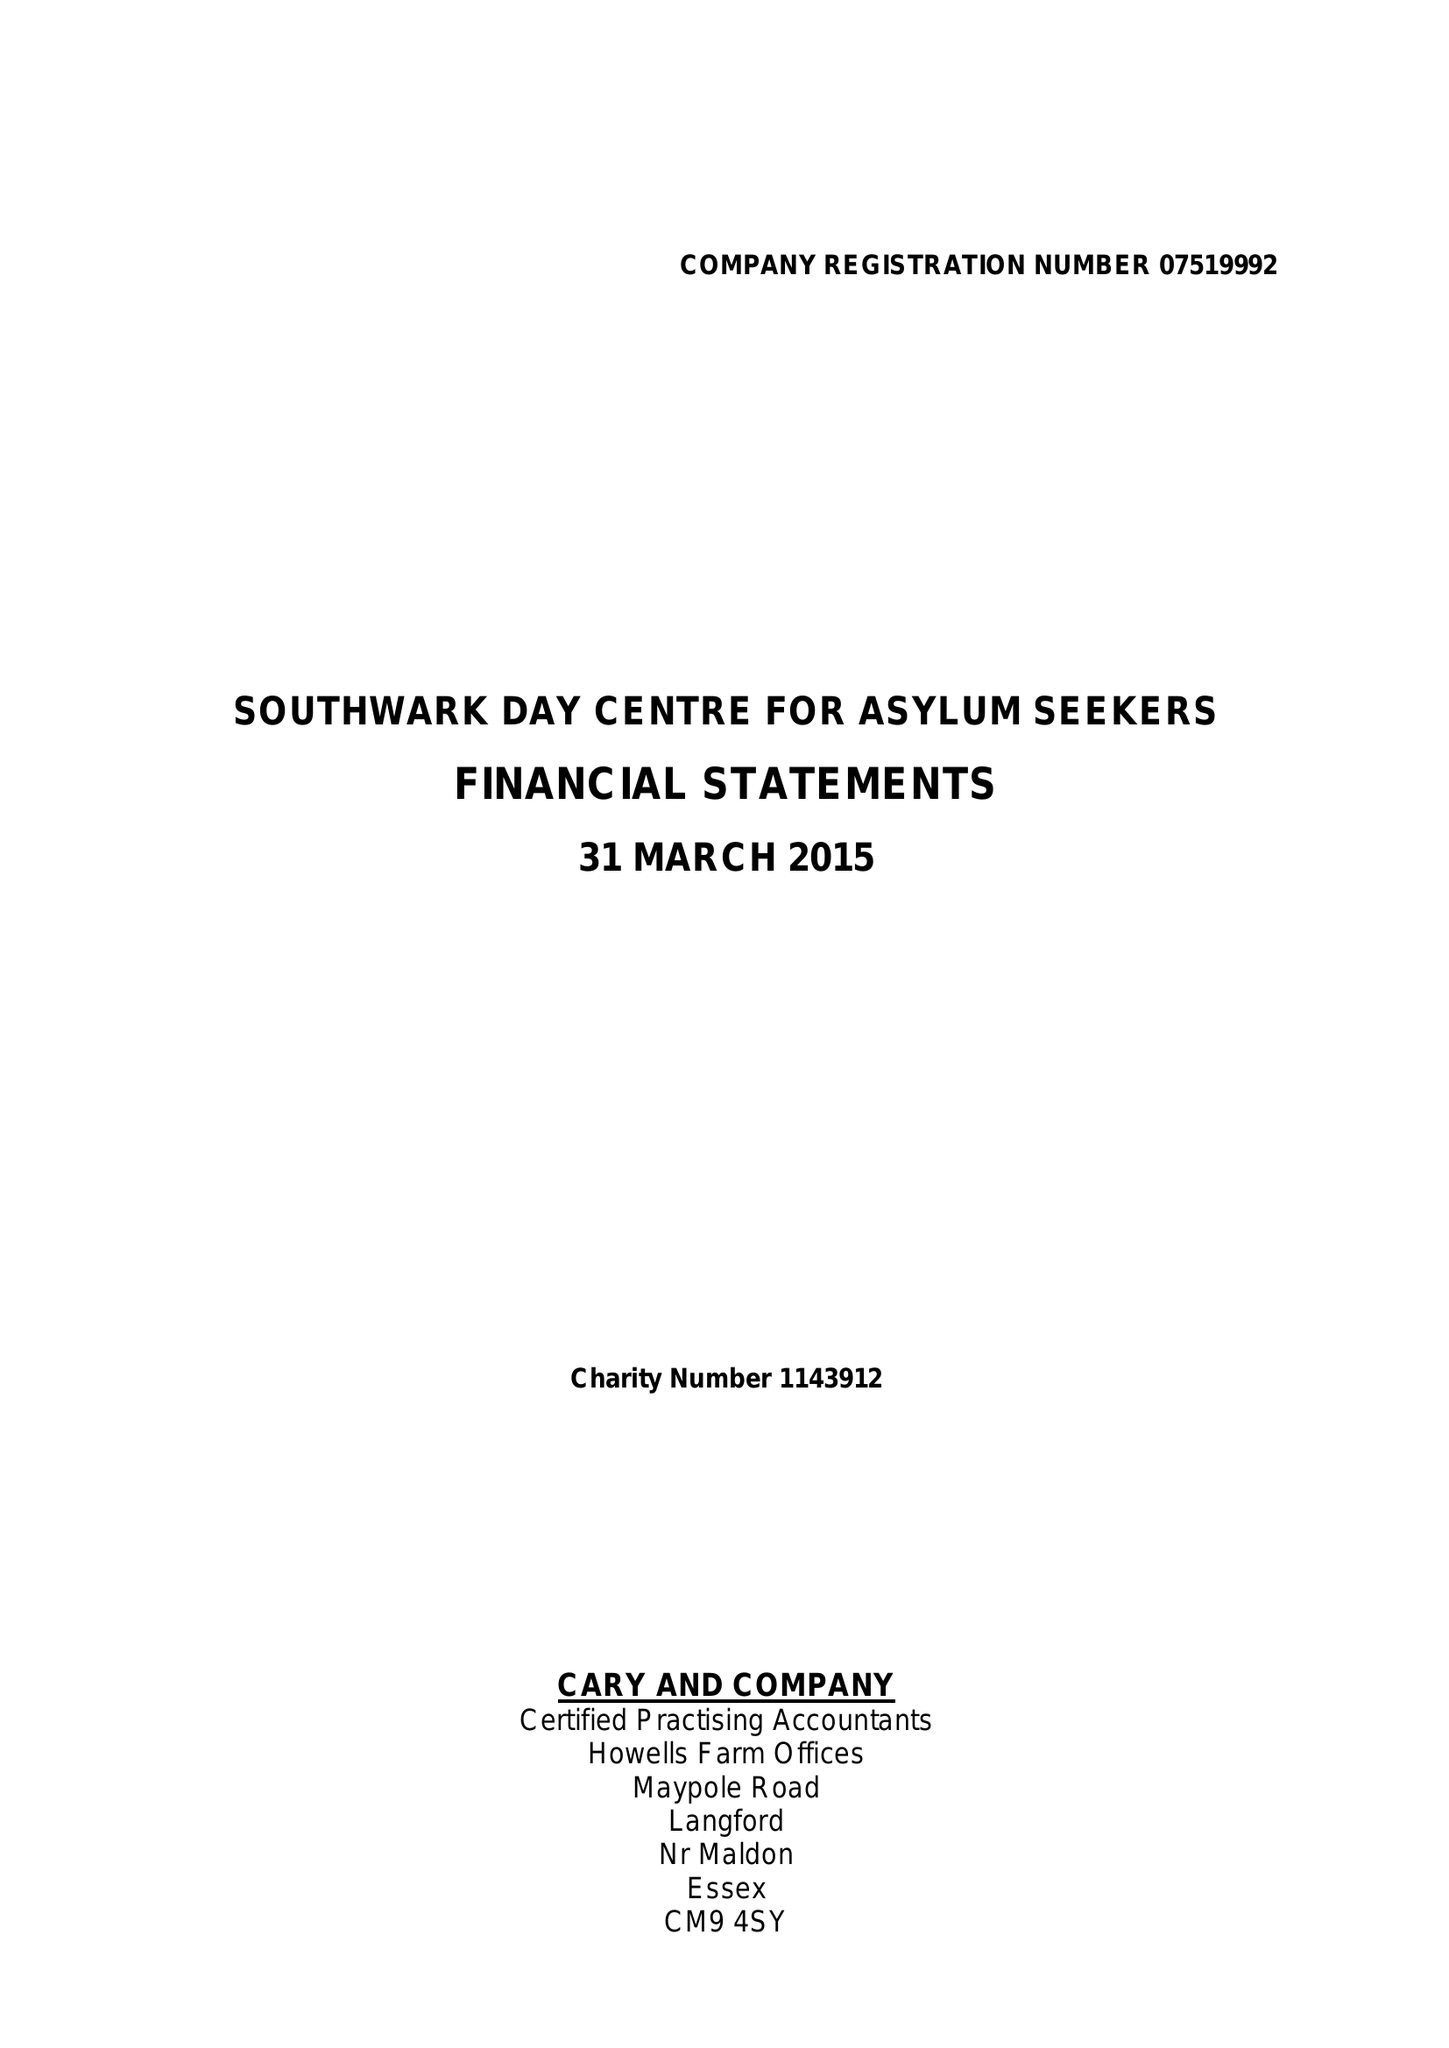What is the value for the report_date?
Answer the question using a single word or phrase. 2015-03-31 